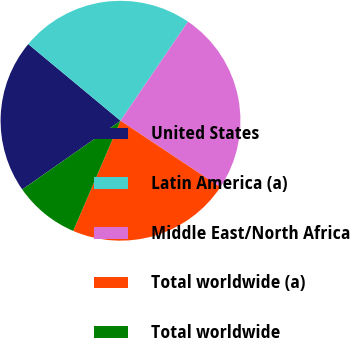<chart> <loc_0><loc_0><loc_500><loc_500><pie_chart><fcel>United States<fcel>Latin America (a)<fcel>Middle East/North Africa<fcel>Total worldwide (a)<fcel>Total worldwide<nl><fcel>20.75%<fcel>23.48%<fcel>24.84%<fcel>22.11%<fcel>8.83%<nl></chart> 